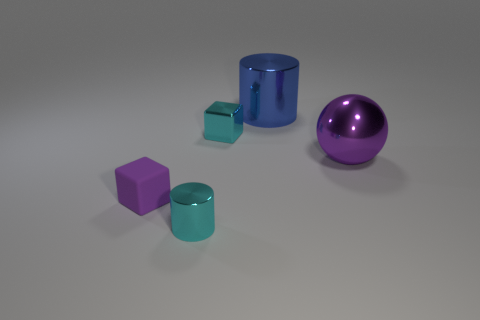Does the sphere have the same color as the matte thing?
Offer a very short reply. Yes. What is the size of the thing that is the same color as the tiny matte cube?
Keep it short and to the point. Large. Are there any cubes of the same color as the big shiny sphere?
Your answer should be compact. Yes. What is the color of the cylinder that is the same size as the purple rubber block?
Offer a very short reply. Cyan. There is a purple object on the right side of the small cyan thing behind the cylinder in front of the blue cylinder; what is its shape?
Offer a terse response. Sphere. How many big blue things are on the right side of the large shiny thing that is behind the big purple thing?
Keep it short and to the point. 0. There is a purple object left of the blue thing; does it have the same shape as the small object right of the cyan shiny cylinder?
Your response must be concise. Yes. There is a tiny purple rubber cube; how many small purple blocks are on the left side of it?
Offer a very short reply. 0. Is the cyan thing that is in front of the large purple ball made of the same material as the sphere?
Offer a terse response. Yes. The tiny purple thing has what shape?
Provide a short and direct response. Cube. 